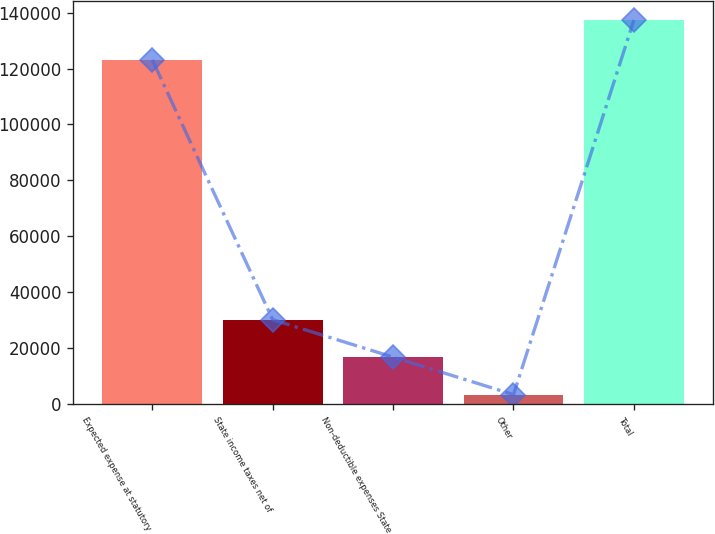<chart> <loc_0><loc_0><loc_500><loc_500><bar_chart><fcel>Expected expense at statutory<fcel>State income taxes net of<fcel>Non-deductible expenses State<fcel>Other<fcel>Total<nl><fcel>123145<fcel>30076.6<fcel>16660.8<fcel>3245<fcel>137403<nl></chart> 